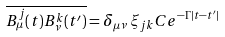Convert formula to latex. <formula><loc_0><loc_0><loc_500><loc_500>\overline { B ^ { j } _ { \mu } ( t ) B ^ { k } _ { \nu } ( t ^ { \prime } ) } = \delta _ { \mu \nu } \, \xi _ { j k } C e ^ { - \Gamma | t - t ^ { \prime } | }</formula> 